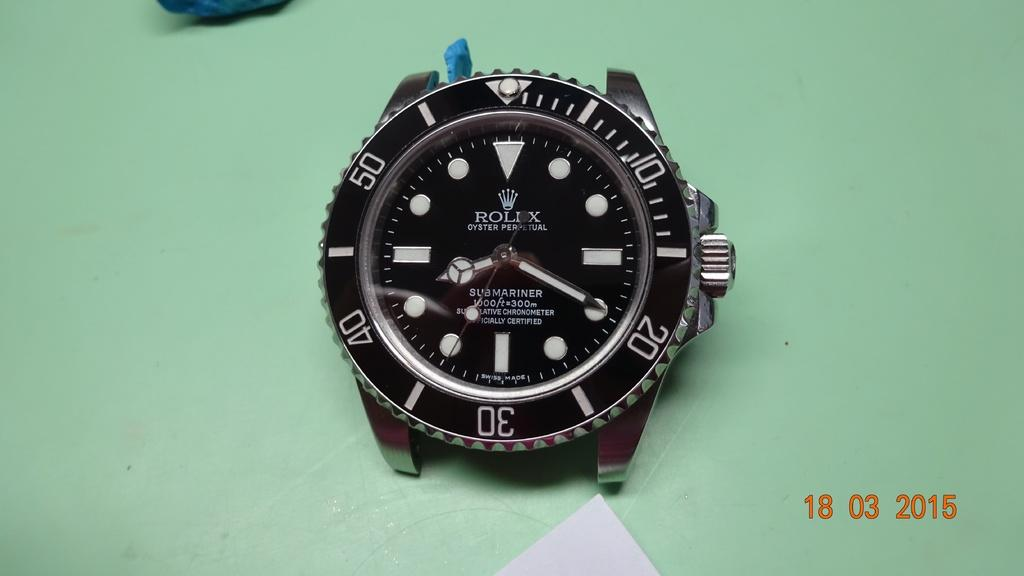<image>
Relay a brief, clear account of the picture shown. the face of a mariner watch, without its band. 